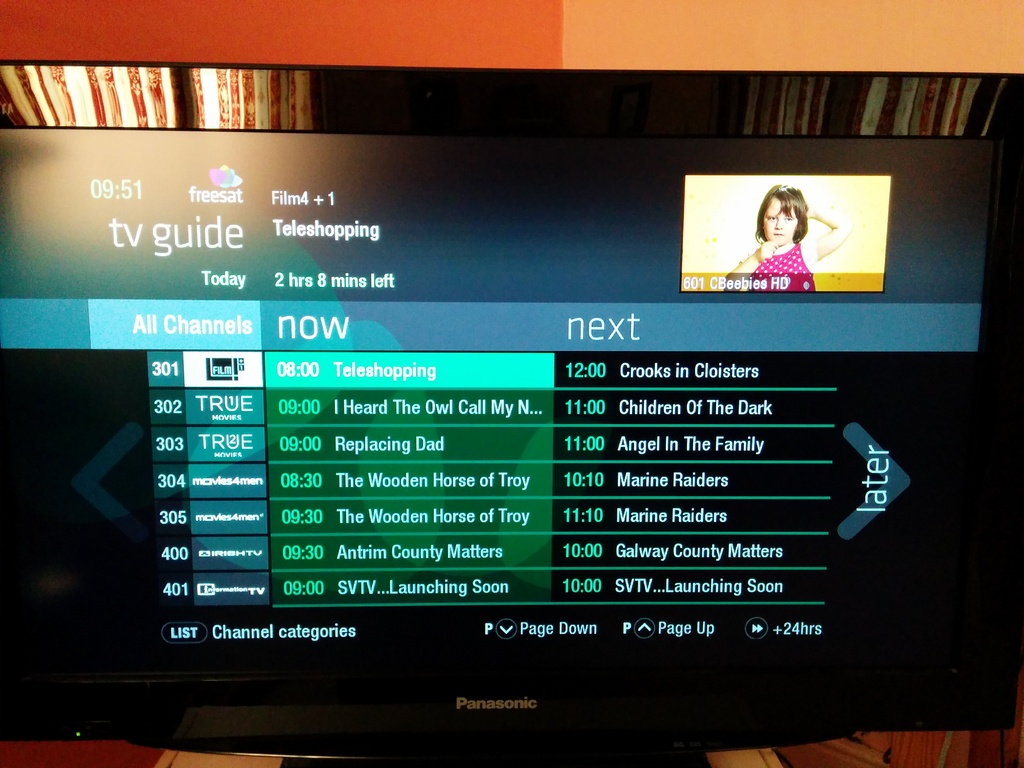Describe what additional information is available on the screen apart from the program listings. Apart from the program listings, the screen also shows the time, 09:51, and provides options at the bottom for different channel categories and functions such as Page Down, Page Up, and +24hrs to navigate through the guide. 